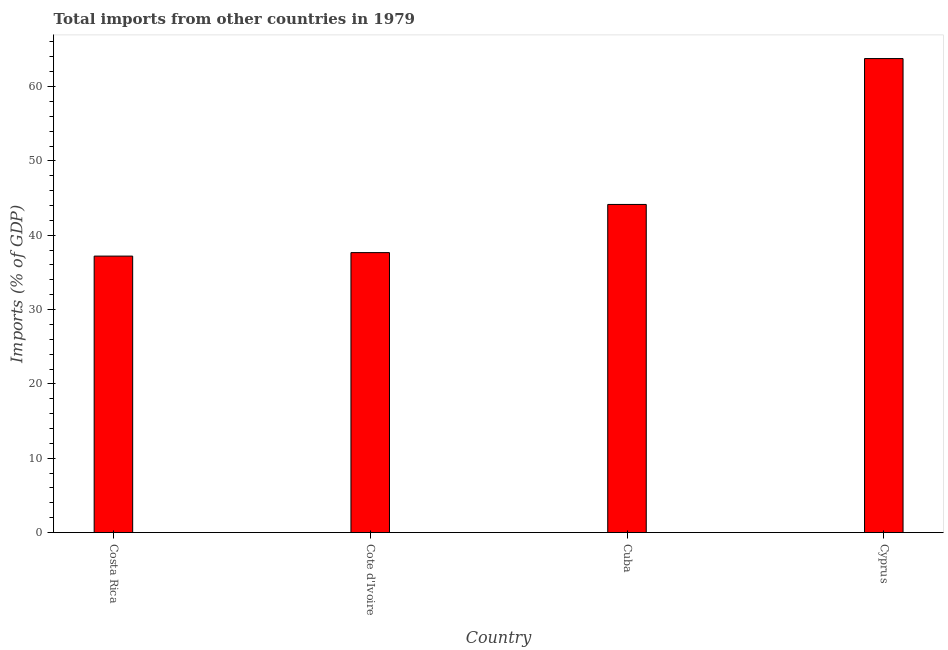Does the graph contain any zero values?
Give a very brief answer. No. What is the title of the graph?
Provide a short and direct response. Total imports from other countries in 1979. What is the label or title of the Y-axis?
Offer a very short reply. Imports (% of GDP). What is the total imports in Costa Rica?
Your answer should be compact. 37.19. Across all countries, what is the maximum total imports?
Offer a terse response. 63.77. Across all countries, what is the minimum total imports?
Your answer should be compact. 37.19. In which country was the total imports maximum?
Ensure brevity in your answer.  Cyprus. What is the sum of the total imports?
Provide a succinct answer. 182.77. What is the difference between the total imports in Costa Rica and Cuba?
Offer a very short reply. -6.95. What is the average total imports per country?
Offer a very short reply. 45.69. What is the median total imports?
Provide a succinct answer. 40.9. In how many countries, is the total imports greater than 48 %?
Make the answer very short. 1. What is the ratio of the total imports in Cuba to that in Cyprus?
Provide a short and direct response. 0.69. Is the total imports in Cuba less than that in Cyprus?
Provide a short and direct response. Yes. What is the difference between the highest and the second highest total imports?
Keep it short and to the point. 19.62. What is the difference between the highest and the lowest total imports?
Your response must be concise. 26.57. Are all the bars in the graph horizontal?
Ensure brevity in your answer.  No. Are the values on the major ticks of Y-axis written in scientific E-notation?
Your answer should be very brief. No. What is the Imports (% of GDP) of Costa Rica?
Keep it short and to the point. 37.19. What is the Imports (% of GDP) in Cote d'Ivoire?
Offer a terse response. 37.66. What is the Imports (% of GDP) in Cuba?
Provide a short and direct response. 44.14. What is the Imports (% of GDP) in Cyprus?
Provide a succinct answer. 63.77. What is the difference between the Imports (% of GDP) in Costa Rica and Cote d'Ivoire?
Offer a very short reply. -0.47. What is the difference between the Imports (% of GDP) in Costa Rica and Cuba?
Your answer should be compact. -6.95. What is the difference between the Imports (% of GDP) in Costa Rica and Cyprus?
Make the answer very short. -26.57. What is the difference between the Imports (% of GDP) in Cote d'Ivoire and Cuba?
Keep it short and to the point. -6.48. What is the difference between the Imports (% of GDP) in Cote d'Ivoire and Cyprus?
Offer a terse response. -26.1. What is the difference between the Imports (% of GDP) in Cuba and Cyprus?
Your response must be concise. -19.62. What is the ratio of the Imports (% of GDP) in Costa Rica to that in Cote d'Ivoire?
Make the answer very short. 0.99. What is the ratio of the Imports (% of GDP) in Costa Rica to that in Cuba?
Offer a terse response. 0.84. What is the ratio of the Imports (% of GDP) in Costa Rica to that in Cyprus?
Provide a succinct answer. 0.58. What is the ratio of the Imports (% of GDP) in Cote d'Ivoire to that in Cuba?
Make the answer very short. 0.85. What is the ratio of the Imports (% of GDP) in Cote d'Ivoire to that in Cyprus?
Ensure brevity in your answer.  0.59. What is the ratio of the Imports (% of GDP) in Cuba to that in Cyprus?
Offer a very short reply. 0.69. 